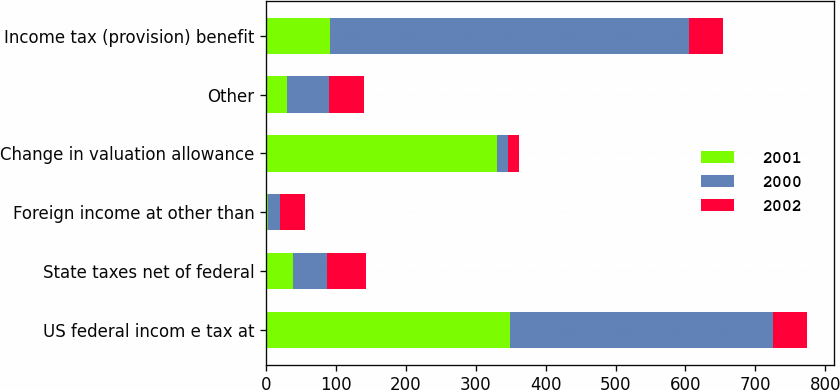Convert chart. <chart><loc_0><loc_0><loc_500><loc_500><stacked_bar_chart><ecel><fcel>US federal incom e tax at<fcel>State taxes net of federal<fcel>Foreign income at other than<fcel>Change in valuation allowance<fcel>Other<fcel>Income tax (provision) benefit<nl><fcel>2001<fcel>349.5<fcel>38.7<fcel>3.2<fcel>330.1<fcel>30.2<fcel>91.5<nl><fcel>2000<fcel>375.2<fcel>47.8<fcel>17.2<fcel>16.6<fcel>59.7<fcel>513.8<nl><fcel>2002<fcel>48.85<fcel>56.4<fcel>35.4<fcel>15.4<fcel>49.9<fcel>48.85<nl></chart> 